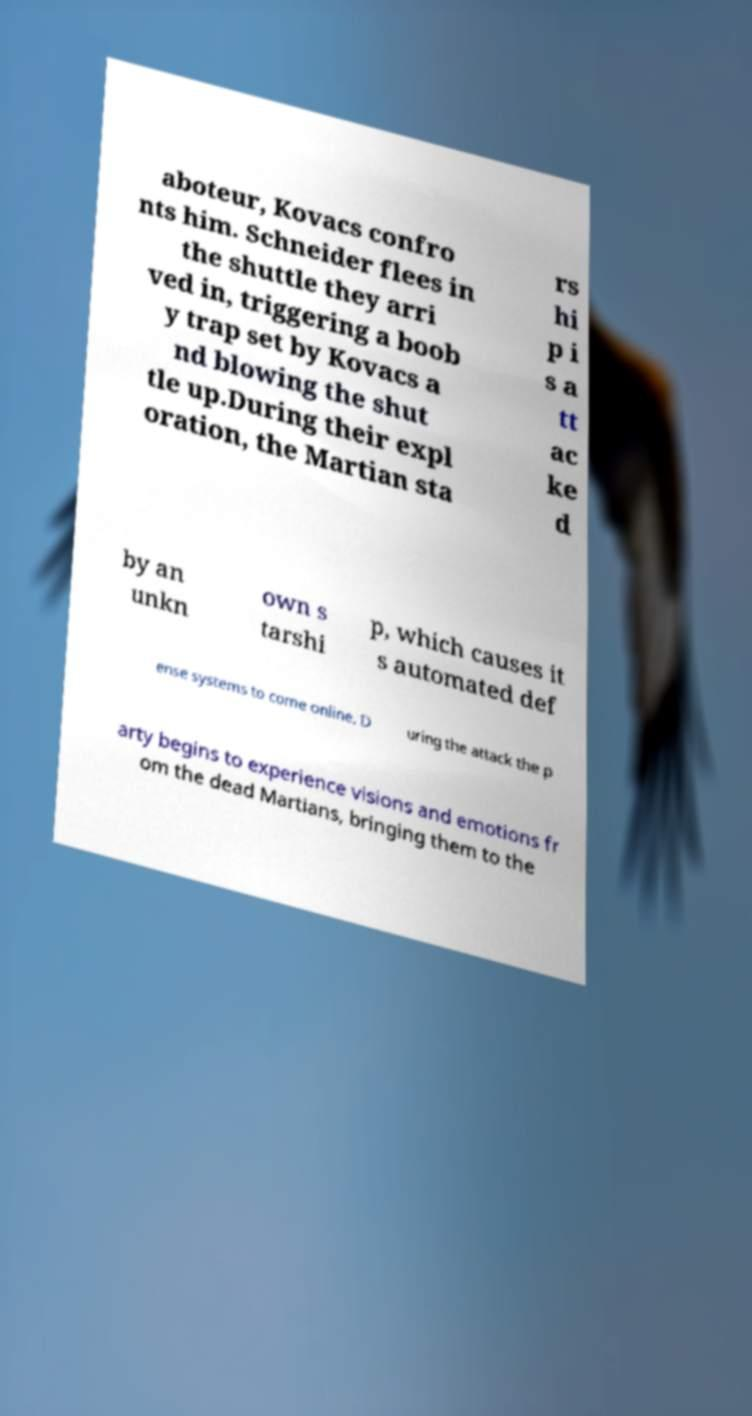Can you accurately transcribe the text from the provided image for me? aboteur, Kovacs confro nts him. Schneider flees in the shuttle they arri ved in, triggering a boob y trap set by Kovacs a nd blowing the shut tle up.During their expl oration, the Martian sta rs hi p i s a tt ac ke d by an unkn own s tarshi p, which causes it s automated def ense systems to come online. D uring the attack the p arty begins to experience visions and emotions fr om the dead Martians, bringing them to the 